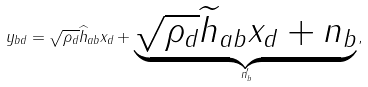<formula> <loc_0><loc_0><loc_500><loc_500>{ y _ { b d } } = \sqrt { \rho _ { d } } \widehat { h } _ { a b } x _ { d } + \underbrace { \sqrt { \rho _ { d } } \widetilde { h } _ { a b } x _ { d } + n _ { b } } _ { n _ { b } ^ { \prime } } ,</formula> 